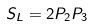<formula> <loc_0><loc_0><loc_500><loc_500>S _ { L } = 2 P _ { 2 } P _ { 3 }</formula> 